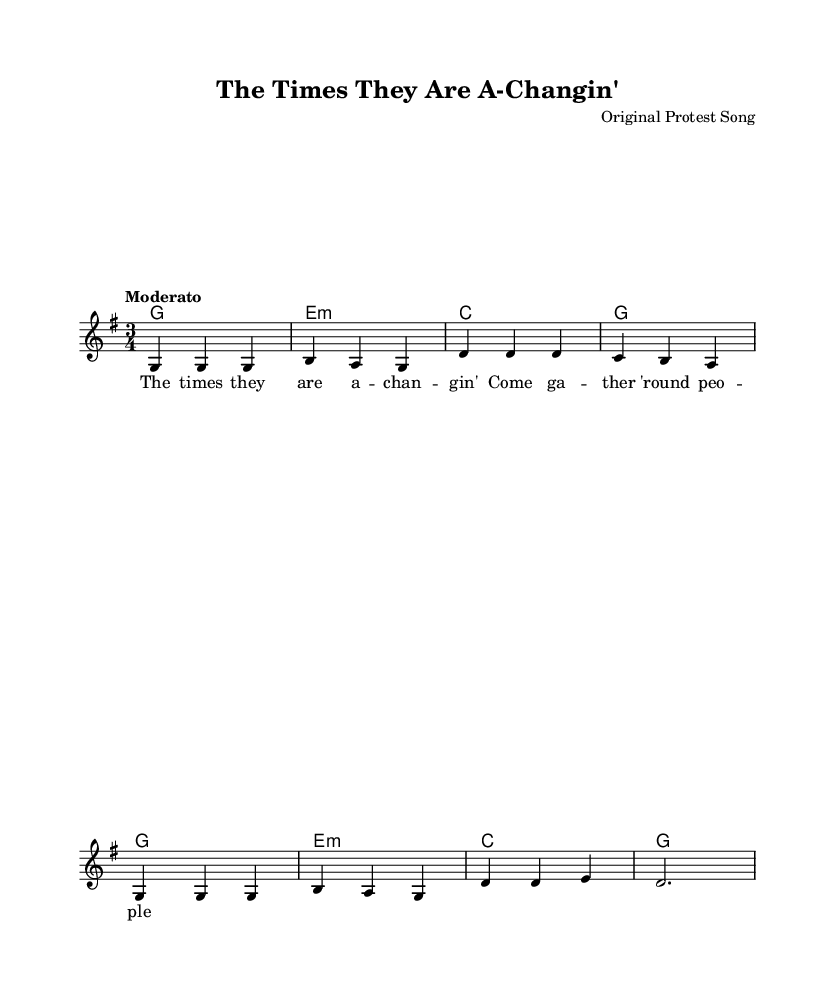What is the key signature of this music? The key signature is G major, which has one sharp (F#). It can be identified on the staff where the F# is marked.
Answer: G major What is the time signature of this music? The time signature is 3/4, which is indicated at the beginning of the piece. This means there are three beats per measure with a quarter note receiving one beat.
Answer: 3/4 What is the tempo marking of this music? The tempo marking is "Moderato," which suggests a moderate pace. This is noted at the beginning of the score as part of the global musical instructions.
Answer: Moderato How many measures are in the melody? The melody consists of eight measures. The measures can be counted along the staff by looking for vertical lines that divide them.
Answer: Eight What chord follows a G major chord in harmony? The chord that follows a G major chord in the harmony is E minor. This can be determined by reading the chord symbols provided beneath the melody line.
Answer: E minor What is the first line of the lyrics? The first line of the lyrics is "The times they are a-changin'" which is placed above the corresponding notes in the staff and indicates where the music corresponds to the lyrics.
Answer: The times they are a-changin' How is the melody mostly structured in terms of pitch? The melody primarily consists of repeated notes and stepwise motion, which can be observed by examining the notes on the staff, as they stay close together and follow a predictable pattern.
Answer: Repeated notes and stepwise motion 